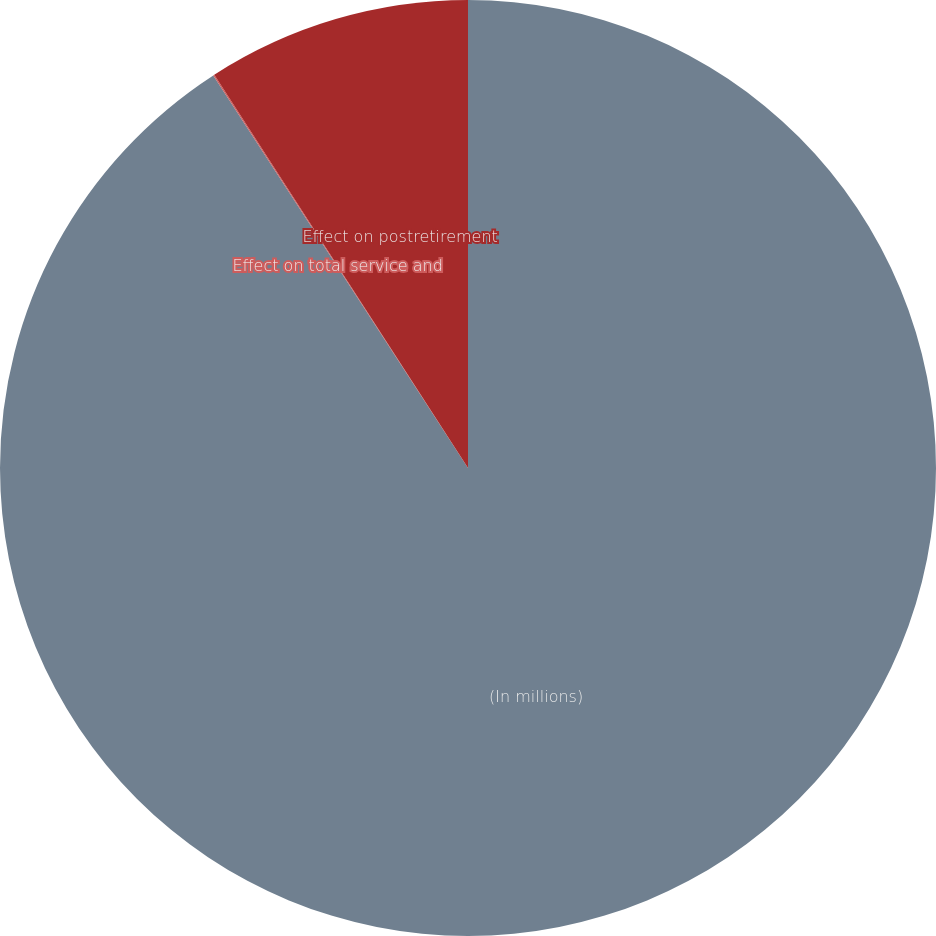<chart> <loc_0><loc_0><loc_500><loc_500><pie_chart><fcel>(In millions)<fcel>Effect on total service and<fcel>Effect on postretirement<nl><fcel>90.84%<fcel>0.04%<fcel>9.12%<nl></chart> 